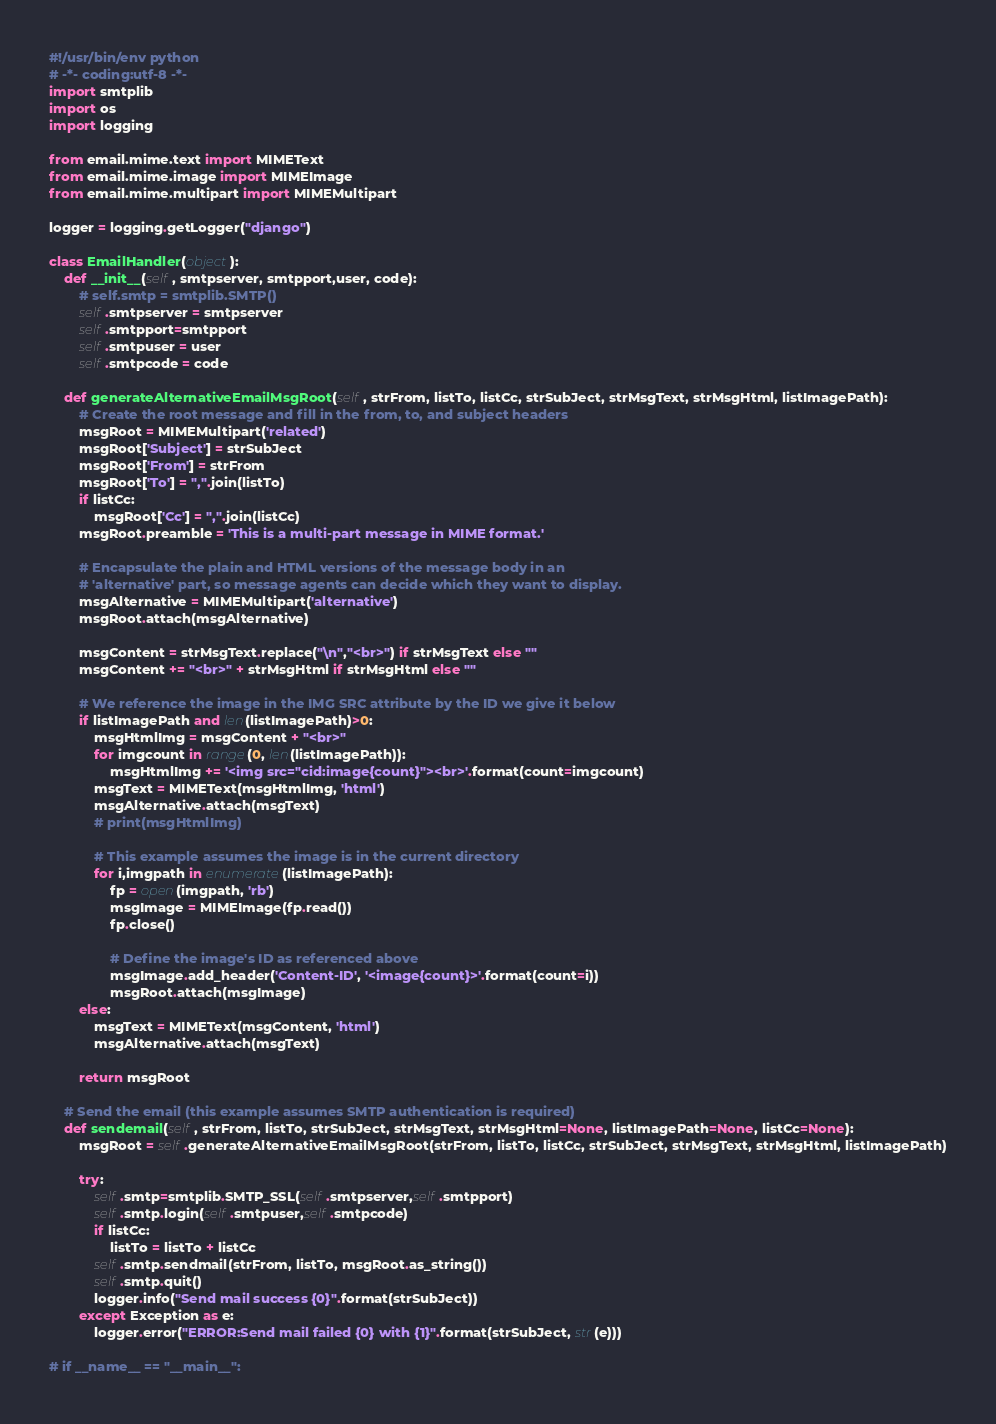<code> <loc_0><loc_0><loc_500><loc_500><_Python_>#!/usr/bin/env python
# -*- coding:utf-8 -*-
import smtplib
import os
import logging

from email.mime.text import MIMEText
from email.mime.image import MIMEImage
from email.mime.multipart import MIMEMultipart

logger = logging.getLogger("django")

class EmailHandler(object):
    def __init__(self, smtpserver, smtpport,user, code):
        # self.smtp = smtplib.SMTP()
        self.smtpserver = smtpserver
        self.smtpport=smtpport
        self.smtpuser = user
        self.smtpcode = code

    def generateAlternativeEmailMsgRoot(self, strFrom, listTo, listCc, strSubJect, strMsgText, strMsgHtml, listImagePath):
        # Create the root message and fill in the from, to, and subject headers
        msgRoot = MIMEMultipart('related')
        msgRoot['Subject'] = strSubJect
        msgRoot['From'] = strFrom
        msgRoot['To'] = ",".join(listTo)
        if listCc:
            msgRoot['Cc'] = ",".join(listCc)
        msgRoot.preamble = 'This is a multi-part message in MIME format.'

        # Encapsulate the plain and HTML versions of the message body in an
        # 'alternative' part, so message agents can decide which they want to display.
        msgAlternative = MIMEMultipart('alternative')
        msgRoot.attach(msgAlternative)

        msgContent = strMsgText.replace("\n","<br>") if strMsgText else ""
        msgContent += "<br>" + strMsgHtml if strMsgHtml else "" 

        # We reference the image in the IMG SRC attribute by the ID we give it below
        if listImagePath and len(listImagePath)>0:
            msgHtmlImg = msgContent + "<br>"
            for imgcount in range(0, len(listImagePath)):
                msgHtmlImg += '<img src="cid:image{count}"><br>'.format(count=imgcount)
            msgText = MIMEText(msgHtmlImg, 'html')
            msgAlternative.attach(msgText)
            # print(msgHtmlImg)

            # This example assumes the image is in the current directory
            for i,imgpath in enumerate(listImagePath):
                fp = open(imgpath, 'rb')
                msgImage = MIMEImage(fp.read())
                fp.close()

                # Define the image's ID as referenced above
                msgImage.add_header('Content-ID', '<image{count}>'.format(count=i))
                msgRoot.attach(msgImage)
        else:
            msgText = MIMEText(msgContent, 'html')
            msgAlternative.attach(msgText)
        
        return msgRoot

    # Send the email (this example assumes SMTP authentication is required)
    def sendemail(self, strFrom, listTo, strSubJect, strMsgText, strMsgHtml=None, listImagePath=None, listCc=None):
        msgRoot = self.generateAlternativeEmailMsgRoot(strFrom, listTo, listCc, strSubJect, strMsgText, strMsgHtml, listImagePath)

        try:
            self.smtp=smtplib.SMTP_SSL(self.smtpserver,self.smtpport)
            self.smtp.login(self.smtpuser,self.smtpcode)
            if listCc:
                listTo = listTo + listCc
            self.smtp.sendmail(strFrom, listTo, msgRoot.as_string())
            self.smtp.quit()
            logger.info("Send mail success {0}".format(strSubJect))
        except Exception as e:
            logger.error("ERROR:Send mail failed {0} with {1}".format(strSubJect, str(e)))

# if __name__ == "__main__": </code> 